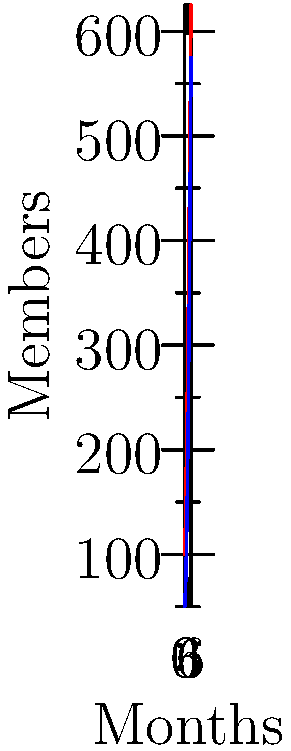Analyze the growth patterns of Community A and Community B over the 6-month period shown in the graph. At what month does the absolute difference in membership between the two communities reach its maximum, and what is this difference? To solve this problem, we need to follow these steps:

1. Calculate the difference in membership between Community A and Community B for each month.
2. Identify the largest difference and the corresponding month.

Let's calculate the differences:

Month 0: $100 - 50 = 50$
Month 1: $150 - 75 = 75$
Month 2: $225 - 125 = 100$
Month 3: $300 - 200 = 100$
Month 4: $400 - 300 = 100$
Month 5: $500 - 425 = 75$
Month 6: $625 - 575 = 50$

The largest difference is 100, which occurs in months 2, 3, and 4. However, the question asks for a single month, so we'll choose the earliest of these, which is month 2.

Therefore, the maximum absolute difference in membership between the two communities is 100, and it first occurs at month 2.
Answer: Month 2, 100 members 